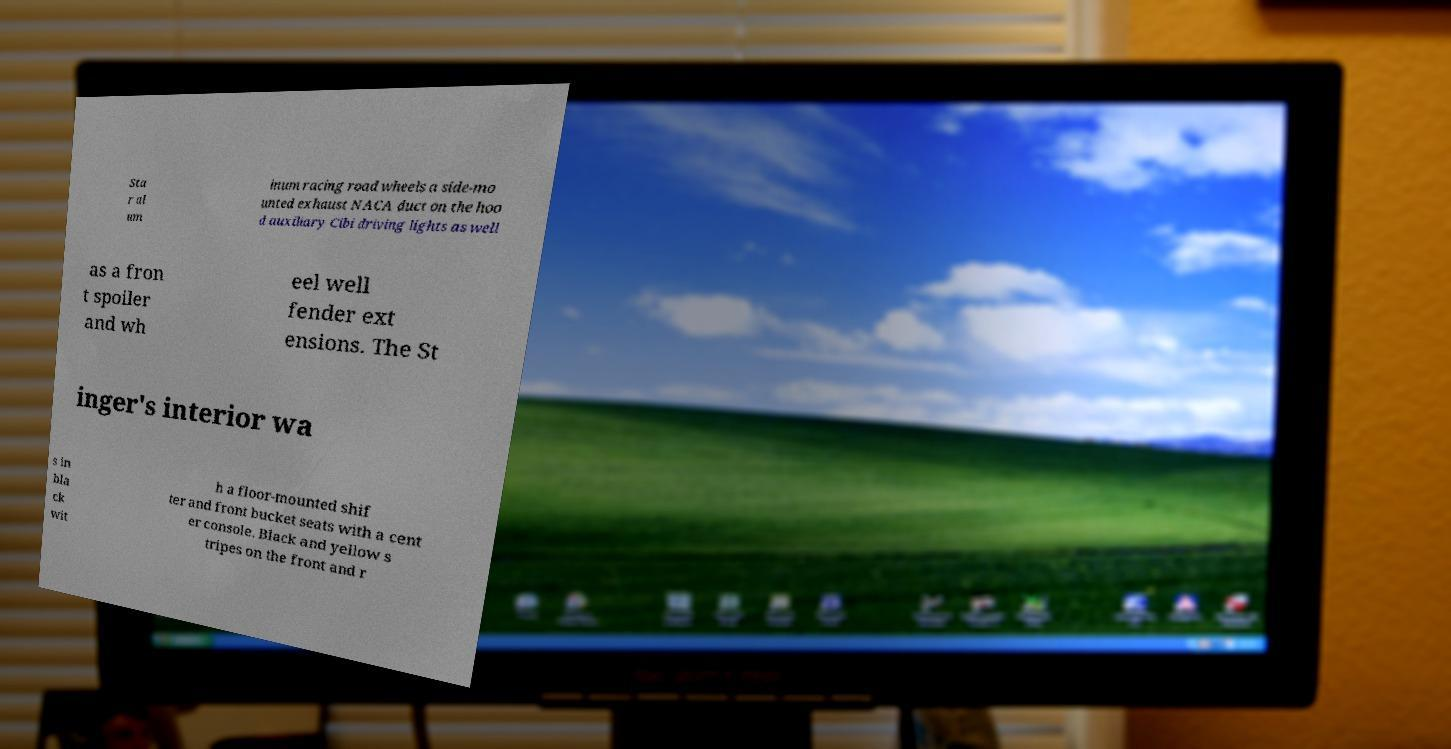Please read and relay the text visible in this image. What does it say? Sta r al um inum racing road wheels a side-mo unted exhaust NACA duct on the hoo d auxiliary Cibi driving lights as well as a fron t spoiler and wh eel well fender ext ensions. The St inger's interior wa s in bla ck wit h a floor-mounted shif ter and front bucket seats with a cent er console. Black and yellow s tripes on the front and r 